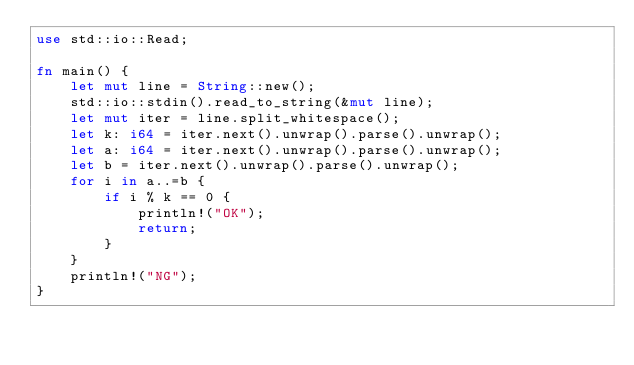<code> <loc_0><loc_0><loc_500><loc_500><_Rust_>use std::io::Read;

fn main() {
    let mut line = String::new();
    std::io::stdin().read_to_string(&mut line);
    let mut iter = line.split_whitespace();
    let k: i64 = iter.next().unwrap().parse().unwrap();
    let a: i64 = iter.next().unwrap().parse().unwrap();
    let b = iter.next().unwrap().parse().unwrap();
    for i in a..=b {
        if i % k == 0 {
            println!("OK");
            return;
        }
    }
    println!("NG");
}
</code> 